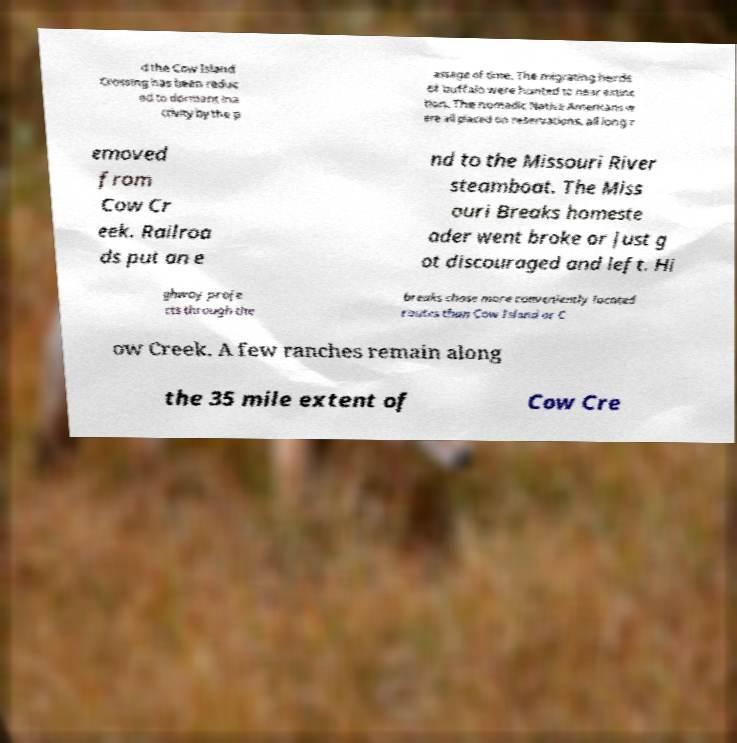Could you extract and type out the text from this image? d the Cow Island Crossing has been reduc ed to dormant ina ctivity by the p assage of time. The migrating herds of buffalo were hunted to near extinc tion. The nomadic Native Americans w ere all placed on reservations, all long r emoved from Cow Cr eek. Railroa ds put an e nd to the Missouri River steamboat. The Miss ouri Breaks homeste ader went broke or just g ot discouraged and left. Hi ghway proje cts through the breaks chose more conveniently located routes than Cow Island or C ow Creek. A few ranches remain along the 35 mile extent of Cow Cre 